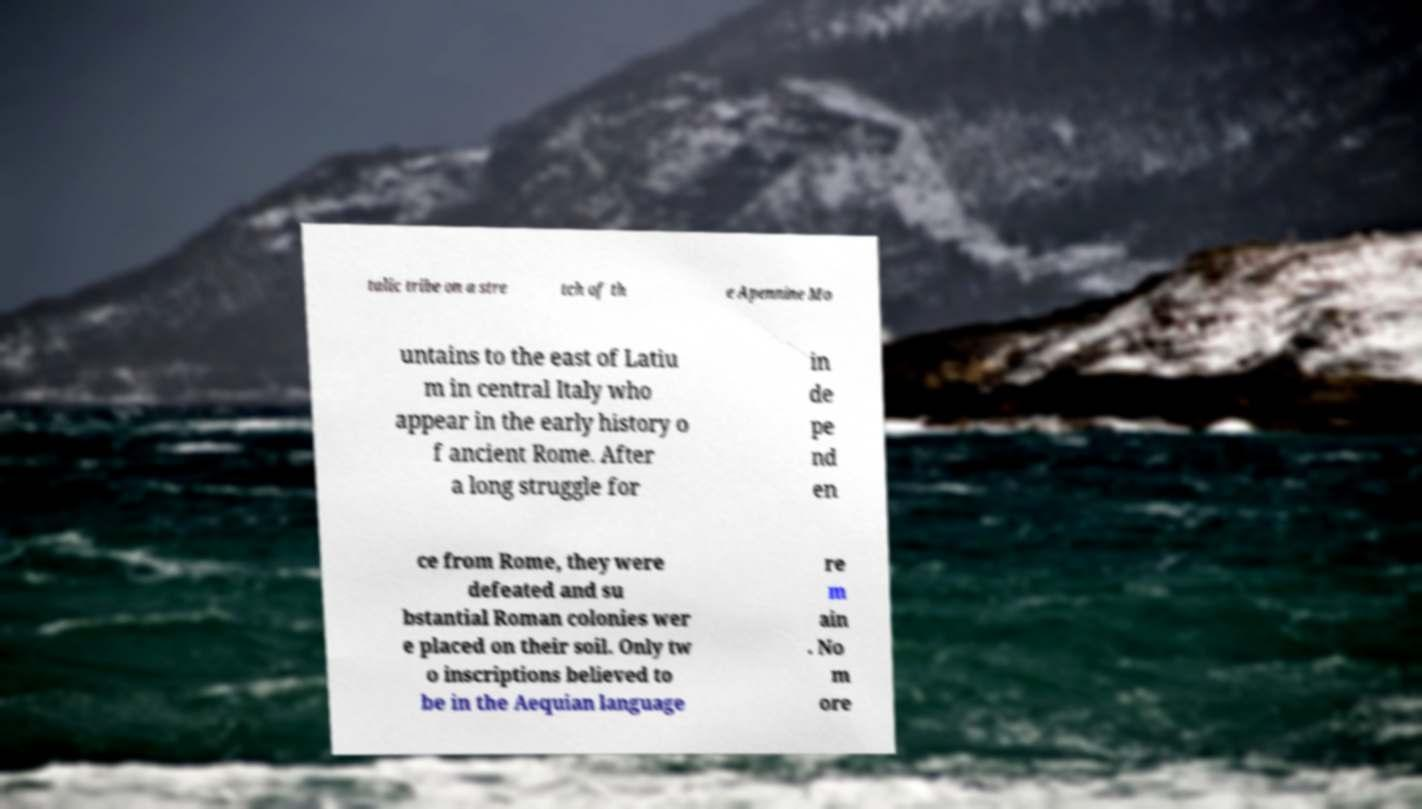I need the written content from this picture converted into text. Can you do that? talic tribe on a stre tch of th e Apennine Mo untains to the east of Latiu m in central Italy who appear in the early history o f ancient Rome. After a long struggle for in de pe nd en ce from Rome, they were defeated and su bstantial Roman colonies wer e placed on their soil. Only tw o inscriptions believed to be in the Aequian language re m ain . No m ore 